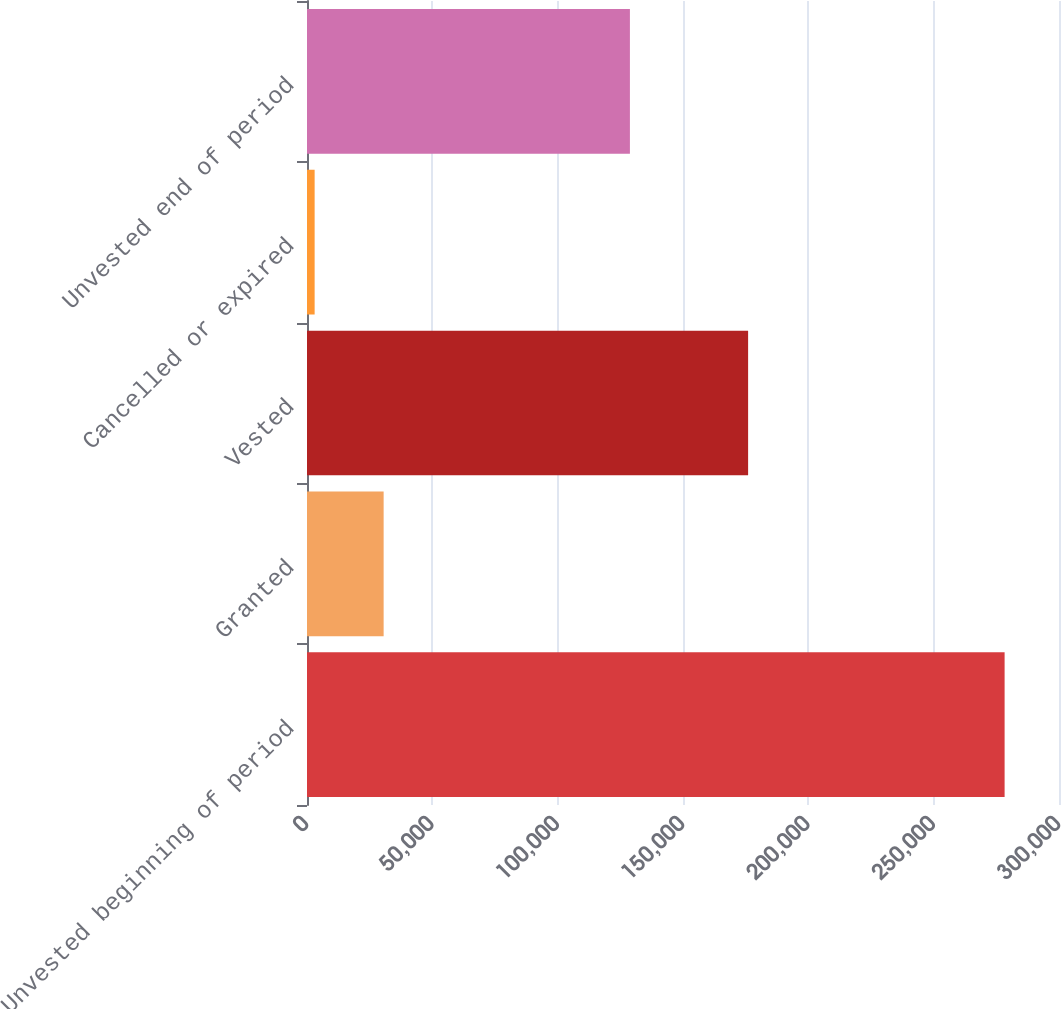Convert chart. <chart><loc_0><loc_0><loc_500><loc_500><bar_chart><fcel>Unvested beginning of period<fcel>Granted<fcel>Vested<fcel>Cancelled or expired<fcel>Unvested end of period<nl><fcel>278301<fcel>30573.3<fcel>175975<fcel>3048<fcel>128822<nl></chart> 